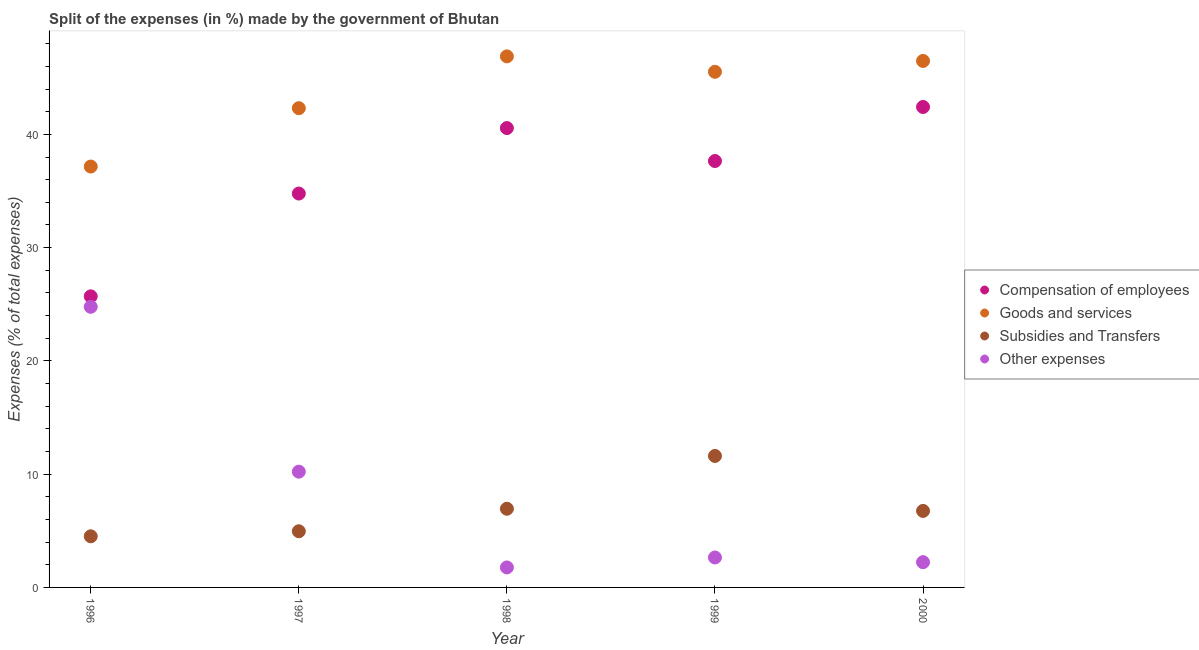Is the number of dotlines equal to the number of legend labels?
Give a very brief answer. Yes. What is the percentage of amount spent on other expenses in 1998?
Provide a short and direct response. 1.76. Across all years, what is the maximum percentage of amount spent on goods and services?
Offer a terse response. 46.88. Across all years, what is the minimum percentage of amount spent on other expenses?
Offer a terse response. 1.76. In which year was the percentage of amount spent on goods and services minimum?
Provide a succinct answer. 1996. What is the total percentage of amount spent on other expenses in the graph?
Provide a short and direct response. 41.63. What is the difference between the percentage of amount spent on compensation of employees in 1996 and that in 2000?
Ensure brevity in your answer.  -16.72. What is the difference between the percentage of amount spent on goods and services in 1996 and the percentage of amount spent on other expenses in 2000?
Provide a succinct answer. 34.93. What is the average percentage of amount spent on subsidies per year?
Your answer should be compact. 6.96. In the year 2000, what is the difference between the percentage of amount spent on goods and services and percentage of amount spent on subsidies?
Your answer should be very brief. 39.73. What is the ratio of the percentage of amount spent on goods and services in 1996 to that in 1998?
Your answer should be very brief. 0.79. What is the difference between the highest and the second highest percentage of amount spent on subsidies?
Your response must be concise. 4.66. What is the difference between the highest and the lowest percentage of amount spent on subsidies?
Ensure brevity in your answer.  7.09. Is the sum of the percentage of amount spent on compensation of employees in 1996 and 1997 greater than the maximum percentage of amount spent on goods and services across all years?
Keep it short and to the point. Yes. Is it the case that in every year, the sum of the percentage of amount spent on goods and services and percentage of amount spent on compensation of employees is greater than the sum of percentage of amount spent on subsidies and percentage of amount spent on other expenses?
Offer a very short reply. Yes. Does the percentage of amount spent on goods and services monotonically increase over the years?
Provide a short and direct response. No. Is the percentage of amount spent on other expenses strictly greater than the percentage of amount spent on compensation of employees over the years?
Provide a succinct answer. No. Is the percentage of amount spent on subsidies strictly less than the percentage of amount spent on other expenses over the years?
Make the answer very short. No. How many years are there in the graph?
Provide a succinct answer. 5. Does the graph contain any zero values?
Ensure brevity in your answer.  No. Does the graph contain grids?
Make the answer very short. No. How are the legend labels stacked?
Keep it short and to the point. Vertical. What is the title of the graph?
Offer a very short reply. Split of the expenses (in %) made by the government of Bhutan. Does "Rule based governance" appear as one of the legend labels in the graph?
Provide a short and direct response. No. What is the label or title of the Y-axis?
Offer a very short reply. Expenses (% of total expenses). What is the Expenses (% of total expenses) of Compensation of employees in 1996?
Give a very brief answer. 25.7. What is the Expenses (% of total expenses) in Goods and services in 1996?
Your response must be concise. 37.16. What is the Expenses (% of total expenses) in Subsidies and Transfers in 1996?
Keep it short and to the point. 4.51. What is the Expenses (% of total expenses) in Other expenses in 1996?
Provide a succinct answer. 24.77. What is the Expenses (% of total expenses) in Compensation of employees in 1997?
Provide a short and direct response. 34.77. What is the Expenses (% of total expenses) in Goods and services in 1997?
Your answer should be very brief. 42.31. What is the Expenses (% of total expenses) of Subsidies and Transfers in 1997?
Your answer should be compact. 4.96. What is the Expenses (% of total expenses) of Other expenses in 1997?
Your answer should be compact. 10.22. What is the Expenses (% of total expenses) of Compensation of employees in 1998?
Give a very brief answer. 40.56. What is the Expenses (% of total expenses) of Goods and services in 1998?
Provide a succinct answer. 46.88. What is the Expenses (% of total expenses) in Subsidies and Transfers in 1998?
Offer a terse response. 6.95. What is the Expenses (% of total expenses) of Other expenses in 1998?
Provide a short and direct response. 1.76. What is the Expenses (% of total expenses) in Compensation of employees in 1999?
Provide a short and direct response. 37.65. What is the Expenses (% of total expenses) in Goods and services in 1999?
Your answer should be compact. 45.52. What is the Expenses (% of total expenses) in Subsidies and Transfers in 1999?
Keep it short and to the point. 11.61. What is the Expenses (% of total expenses) in Other expenses in 1999?
Your response must be concise. 2.64. What is the Expenses (% of total expenses) of Compensation of employees in 2000?
Your response must be concise. 42.42. What is the Expenses (% of total expenses) of Goods and services in 2000?
Provide a short and direct response. 46.48. What is the Expenses (% of total expenses) in Subsidies and Transfers in 2000?
Provide a succinct answer. 6.76. What is the Expenses (% of total expenses) in Other expenses in 2000?
Offer a terse response. 2.23. Across all years, what is the maximum Expenses (% of total expenses) of Compensation of employees?
Offer a terse response. 42.42. Across all years, what is the maximum Expenses (% of total expenses) in Goods and services?
Provide a succinct answer. 46.88. Across all years, what is the maximum Expenses (% of total expenses) of Subsidies and Transfers?
Offer a very short reply. 11.61. Across all years, what is the maximum Expenses (% of total expenses) of Other expenses?
Offer a terse response. 24.77. Across all years, what is the minimum Expenses (% of total expenses) in Compensation of employees?
Offer a very short reply. 25.7. Across all years, what is the minimum Expenses (% of total expenses) of Goods and services?
Provide a short and direct response. 37.16. Across all years, what is the minimum Expenses (% of total expenses) in Subsidies and Transfers?
Offer a terse response. 4.51. Across all years, what is the minimum Expenses (% of total expenses) in Other expenses?
Your answer should be compact. 1.76. What is the total Expenses (% of total expenses) in Compensation of employees in the graph?
Provide a succinct answer. 181.09. What is the total Expenses (% of total expenses) in Goods and services in the graph?
Keep it short and to the point. 218.35. What is the total Expenses (% of total expenses) in Subsidies and Transfers in the graph?
Offer a very short reply. 34.78. What is the total Expenses (% of total expenses) in Other expenses in the graph?
Your response must be concise. 41.63. What is the difference between the Expenses (% of total expenses) of Compensation of employees in 1996 and that in 1997?
Give a very brief answer. -9.07. What is the difference between the Expenses (% of total expenses) of Goods and services in 1996 and that in 1997?
Provide a succinct answer. -5.15. What is the difference between the Expenses (% of total expenses) of Subsidies and Transfers in 1996 and that in 1997?
Ensure brevity in your answer.  -0.44. What is the difference between the Expenses (% of total expenses) of Other expenses in 1996 and that in 1997?
Your response must be concise. 14.55. What is the difference between the Expenses (% of total expenses) of Compensation of employees in 1996 and that in 1998?
Provide a succinct answer. -14.86. What is the difference between the Expenses (% of total expenses) in Goods and services in 1996 and that in 1998?
Offer a terse response. -9.73. What is the difference between the Expenses (% of total expenses) in Subsidies and Transfers in 1996 and that in 1998?
Your answer should be compact. -2.43. What is the difference between the Expenses (% of total expenses) in Other expenses in 1996 and that in 1998?
Your response must be concise. 23.01. What is the difference between the Expenses (% of total expenses) of Compensation of employees in 1996 and that in 1999?
Your answer should be very brief. -11.95. What is the difference between the Expenses (% of total expenses) in Goods and services in 1996 and that in 1999?
Your answer should be compact. -8.36. What is the difference between the Expenses (% of total expenses) of Subsidies and Transfers in 1996 and that in 1999?
Your answer should be very brief. -7.09. What is the difference between the Expenses (% of total expenses) of Other expenses in 1996 and that in 1999?
Provide a short and direct response. 22.13. What is the difference between the Expenses (% of total expenses) of Compensation of employees in 1996 and that in 2000?
Your answer should be very brief. -16.72. What is the difference between the Expenses (% of total expenses) in Goods and services in 1996 and that in 2000?
Provide a succinct answer. -9.32. What is the difference between the Expenses (% of total expenses) of Subsidies and Transfers in 1996 and that in 2000?
Offer a very short reply. -2.24. What is the difference between the Expenses (% of total expenses) of Other expenses in 1996 and that in 2000?
Offer a terse response. 22.55. What is the difference between the Expenses (% of total expenses) of Compensation of employees in 1997 and that in 1998?
Provide a succinct answer. -5.78. What is the difference between the Expenses (% of total expenses) in Goods and services in 1997 and that in 1998?
Your answer should be compact. -4.57. What is the difference between the Expenses (% of total expenses) of Subsidies and Transfers in 1997 and that in 1998?
Give a very brief answer. -1.99. What is the difference between the Expenses (% of total expenses) of Other expenses in 1997 and that in 1998?
Make the answer very short. 8.46. What is the difference between the Expenses (% of total expenses) of Compensation of employees in 1997 and that in 1999?
Offer a terse response. -2.87. What is the difference between the Expenses (% of total expenses) in Goods and services in 1997 and that in 1999?
Make the answer very short. -3.21. What is the difference between the Expenses (% of total expenses) in Subsidies and Transfers in 1997 and that in 1999?
Offer a very short reply. -6.65. What is the difference between the Expenses (% of total expenses) in Other expenses in 1997 and that in 1999?
Provide a short and direct response. 7.58. What is the difference between the Expenses (% of total expenses) of Compensation of employees in 1997 and that in 2000?
Keep it short and to the point. -7.64. What is the difference between the Expenses (% of total expenses) in Goods and services in 1997 and that in 2000?
Your answer should be compact. -4.17. What is the difference between the Expenses (% of total expenses) of Subsidies and Transfers in 1997 and that in 2000?
Your answer should be compact. -1.8. What is the difference between the Expenses (% of total expenses) in Other expenses in 1997 and that in 2000?
Offer a terse response. 7.99. What is the difference between the Expenses (% of total expenses) of Compensation of employees in 1998 and that in 1999?
Make the answer very short. 2.91. What is the difference between the Expenses (% of total expenses) in Goods and services in 1998 and that in 1999?
Provide a short and direct response. 1.36. What is the difference between the Expenses (% of total expenses) of Subsidies and Transfers in 1998 and that in 1999?
Provide a succinct answer. -4.66. What is the difference between the Expenses (% of total expenses) in Other expenses in 1998 and that in 1999?
Give a very brief answer. -0.88. What is the difference between the Expenses (% of total expenses) of Compensation of employees in 1998 and that in 2000?
Make the answer very short. -1.86. What is the difference between the Expenses (% of total expenses) of Goods and services in 1998 and that in 2000?
Keep it short and to the point. 0.4. What is the difference between the Expenses (% of total expenses) in Subsidies and Transfers in 1998 and that in 2000?
Give a very brief answer. 0.19. What is the difference between the Expenses (% of total expenses) of Other expenses in 1998 and that in 2000?
Make the answer very short. -0.46. What is the difference between the Expenses (% of total expenses) of Compensation of employees in 1999 and that in 2000?
Provide a succinct answer. -4.77. What is the difference between the Expenses (% of total expenses) of Goods and services in 1999 and that in 2000?
Give a very brief answer. -0.96. What is the difference between the Expenses (% of total expenses) in Subsidies and Transfers in 1999 and that in 2000?
Provide a short and direct response. 4.85. What is the difference between the Expenses (% of total expenses) in Other expenses in 1999 and that in 2000?
Give a very brief answer. 0.41. What is the difference between the Expenses (% of total expenses) in Compensation of employees in 1996 and the Expenses (% of total expenses) in Goods and services in 1997?
Your answer should be compact. -16.61. What is the difference between the Expenses (% of total expenses) in Compensation of employees in 1996 and the Expenses (% of total expenses) in Subsidies and Transfers in 1997?
Provide a short and direct response. 20.74. What is the difference between the Expenses (% of total expenses) of Compensation of employees in 1996 and the Expenses (% of total expenses) of Other expenses in 1997?
Your answer should be very brief. 15.48. What is the difference between the Expenses (% of total expenses) of Goods and services in 1996 and the Expenses (% of total expenses) of Subsidies and Transfers in 1997?
Offer a very short reply. 32.2. What is the difference between the Expenses (% of total expenses) in Goods and services in 1996 and the Expenses (% of total expenses) in Other expenses in 1997?
Offer a very short reply. 26.94. What is the difference between the Expenses (% of total expenses) of Subsidies and Transfers in 1996 and the Expenses (% of total expenses) of Other expenses in 1997?
Make the answer very short. -5.71. What is the difference between the Expenses (% of total expenses) of Compensation of employees in 1996 and the Expenses (% of total expenses) of Goods and services in 1998?
Give a very brief answer. -21.18. What is the difference between the Expenses (% of total expenses) in Compensation of employees in 1996 and the Expenses (% of total expenses) in Subsidies and Transfers in 1998?
Provide a short and direct response. 18.75. What is the difference between the Expenses (% of total expenses) of Compensation of employees in 1996 and the Expenses (% of total expenses) of Other expenses in 1998?
Keep it short and to the point. 23.93. What is the difference between the Expenses (% of total expenses) of Goods and services in 1996 and the Expenses (% of total expenses) of Subsidies and Transfers in 1998?
Make the answer very short. 30.21. What is the difference between the Expenses (% of total expenses) of Goods and services in 1996 and the Expenses (% of total expenses) of Other expenses in 1998?
Make the answer very short. 35.39. What is the difference between the Expenses (% of total expenses) of Subsidies and Transfers in 1996 and the Expenses (% of total expenses) of Other expenses in 1998?
Offer a terse response. 2.75. What is the difference between the Expenses (% of total expenses) of Compensation of employees in 1996 and the Expenses (% of total expenses) of Goods and services in 1999?
Your answer should be compact. -19.82. What is the difference between the Expenses (% of total expenses) in Compensation of employees in 1996 and the Expenses (% of total expenses) in Subsidies and Transfers in 1999?
Keep it short and to the point. 14.09. What is the difference between the Expenses (% of total expenses) of Compensation of employees in 1996 and the Expenses (% of total expenses) of Other expenses in 1999?
Offer a very short reply. 23.06. What is the difference between the Expenses (% of total expenses) of Goods and services in 1996 and the Expenses (% of total expenses) of Subsidies and Transfers in 1999?
Make the answer very short. 25.55. What is the difference between the Expenses (% of total expenses) in Goods and services in 1996 and the Expenses (% of total expenses) in Other expenses in 1999?
Provide a succinct answer. 34.51. What is the difference between the Expenses (% of total expenses) of Subsidies and Transfers in 1996 and the Expenses (% of total expenses) of Other expenses in 1999?
Keep it short and to the point. 1.87. What is the difference between the Expenses (% of total expenses) in Compensation of employees in 1996 and the Expenses (% of total expenses) in Goods and services in 2000?
Offer a very short reply. -20.78. What is the difference between the Expenses (% of total expenses) in Compensation of employees in 1996 and the Expenses (% of total expenses) in Subsidies and Transfers in 2000?
Provide a succinct answer. 18.94. What is the difference between the Expenses (% of total expenses) in Compensation of employees in 1996 and the Expenses (% of total expenses) in Other expenses in 2000?
Provide a succinct answer. 23.47. What is the difference between the Expenses (% of total expenses) of Goods and services in 1996 and the Expenses (% of total expenses) of Subsidies and Transfers in 2000?
Your response must be concise. 30.4. What is the difference between the Expenses (% of total expenses) in Goods and services in 1996 and the Expenses (% of total expenses) in Other expenses in 2000?
Your answer should be very brief. 34.93. What is the difference between the Expenses (% of total expenses) in Subsidies and Transfers in 1996 and the Expenses (% of total expenses) in Other expenses in 2000?
Offer a terse response. 2.28. What is the difference between the Expenses (% of total expenses) in Compensation of employees in 1997 and the Expenses (% of total expenses) in Goods and services in 1998?
Your answer should be very brief. -12.11. What is the difference between the Expenses (% of total expenses) of Compensation of employees in 1997 and the Expenses (% of total expenses) of Subsidies and Transfers in 1998?
Your answer should be compact. 27.83. What is the difference between the Expenses (% of total expenses) of Compensation of employees in 1997 and the Expenses (% of total expenses) of Other expenses in 1998?
Provide a succinct answer. 33.01. What is the difference between the Expenses (% of total expenses) of Goods and services in 1997 and the Expenses (% of total expenses) of Subsidies and Transfers in 1998?
Your answer should be compact. 35.36. What is the difference between the Expenses (% of total expenses) of Goods and services in 1997 and the Expenses (% of total expenses) of Other expenses in 1998?
Offer a terse response. 40.54. What is the difference between the Expenses (% of total expenses) of Subsidies and Transfers in 1997 and the Expenses (% of total expenses) of Other expenses in 1998?
Provide a short and direct response. 3.19. What is the difference between the Expenses (% of total expenses) of Compensation of employees in 1997 and the Expenses (% of total expenses) of Goods and services in 1999?
Keep it short and to the point. -10.75. What is the difference between the Expenses (% of total expenses) of Compensation of employees in 1997 and the Expenses (% of total expenses) of Subsidies and Transfers in 1999?
Keep it short and to the point. 23.17. What is the difference between the Expenses (% of total expenses) in Compensation of employees in 1997 and the Expenses (% of total expenses) in Other expenses in 1999?
Your response must be concise. 32.13. What is the difference between the Expenses (% of total expenses) in Goods and services in 1997 and the Expenses (% of total expenses) in Subsidies and Transfers in 1999?
Offer a terse response. 30.7. What is the difference between the Expenses (% of total expenses) in Goods and services in 1997 and the Expenses (% of total expenses) in Other expenses in 1999?
Provide a succinct answer. 39.67. What is the difference between the Expenses (% of total expenses) in Subsidies and Transfers in 1997 and the Expenses (% of total expenses) in Other expenses in 1999?
Your answer should be very brief. 2.31. What is the difference between the Expenses (% of total expenses) of Compensation of employees in 1997 and the Expenses (% of total expenses) of Goods and services in 2000?
Make the answer very short. -11.71. What is the difference between the Expenses (% of total expenses) in Compensation of employees in 1997 and the Expenses (% of total expenses) in Subsidies and Transfers in 2000?
Your response must be concise. 28.02. What is the difference between the Expenses (% of total expenses) in Compensation of employees in 1997 and the Expenses (% of total expenses) in Other expenses in 2000?
Provide a short and direct response. 32.55. What is the difference between the Expenses (% of total expenses) of Goods and services in 1997 and the Expenses (% of total expenses) of Subsidies and Transfers in 2000?
Provide a short and direct response. 35.55. What is the difference between the Expenses (% of total expenses) of Goods and services in 1997 and the Expenses (% of total expenses) of Other expenses in 2000?
Keep it short and to the point. 40.08. What is the difference between the Expenses (% of total expenses) of Subsidies and Transfers in 1997 and the Expenses (% of total expenses) of Other expenses in 2000?
Make the answer very short. 2.73. What is the difference between the Expenses (% of total expenses) of Compensation of employees in 1998 and the Expenses (% of total expenses) of Goods and services in 1999?
Keep it short and to the point. -4.97. What is the difference between the Expenses (% of total expenses) of Compensation of employees in 1998 and the Expenses (% of total expenses) of Subsidies and Transfers in 1999?
Ensure brevity in your answer.  28.95. What is the difference between the Expenses (% of total expenses) of Compensation of employees in 1998 and the Expenses (% of total expenses) of Other expenses in 1999?
Your answer should be compact. 37.91. What is the difference between the Expenses (% of total expenses) of Goods and services in 1998 and the Expenses (% of total expenses) of Subsidies and Transfers in 1999?
Provide a short and direct response. 35.28. What is the difference between the Expenses (% of total expenses) of Goods and services in 1998 and the Expenses (% of total expenses) of Other expenses in 1999?
Make the answer very short. 44.24. What is the difference between the Expenses (% of total expenses) in Subsidies and Transfers in 1998 and the Expenses (% of total expenses) in Other expenses in 1999?
Make the answer very short. 4.3. What is the difference between the Expenses (% of total expenses) of Compensation of employees in 1998 and the Expenses (% of total expenses) of Goods and services in 2000?
Keep it short and to the point. -5.93. What is the difference between the Expenses (% of total expenses) in Compensation of employees in 1998 and the Expenses (% of total expenses) in Subsidies and Transfers in 2000?
Offer a terse response. 33.8. What is the difference between the Expenses (% of total expenses) of Compensation of employees in 1998 and the Expenses (% of total expenses) of Other expenses in 2000?
Make the answer very short. 38.33. What is the difference between the Expenses (% of total expenses) in Goods and services in 1998 and the Expenses (% of total expenses) in Subsidies and Transfers in 2000?
Provide a succinct answer. 40.13. What is the difference between the Expenses (% of total expenses) in Goods and services in 1998 and the Expenses (% of total expenses) in Other expenses in 2000?
Your response must be concise. 44.66. What is the difference between the Expenses (% of total expenses) of Subsidies and Transfers in 1998 and the Expenses (% of total expenses) of Other expenses in 2000?
Provide a short and direct response. 4.72. What is the difference between the Expenses (% of total expenses) in Compensation of employees in 1999 and the Expenses (% of total expenses) in Goods and services in 2000?
Your response must be concise. -8.83. What is the difference between the Expenses (% of total expenses) of Compensation of employees in 1999 and the Expenses (% of total expenses) of Subsidies and Transfers in 2000?
Make the answer very short. 30.89. What is the difference between the Expenses (% of total expenses) of Compensation of employees in 1999 and the Expenses (% of total expenses) of Other expenses in 2000?
Provide a succinct answer. 35.42. What is the difference between the Expenses (% of total expenses) of Goods and services in 1999 and the Expenses (% of total expenses) of Subsidies and Transfers in 2000?
Your answer should be very brief. 38.77. What is the difference between the Expenses (% of total expenses) of Goods and services in 1999 and the Expenses (% of total expenses) of Other expenses in 2000?
Provide a succinct answer. 43.29. What is the difference between the Expenses (% of total expenses) in Subsidies and Transfers in 1999 and the Expenses (% of total expenses) in Other expenses in 2000?
Your answer should be very brief. 9.38. What is the average Expenses (% of total expenses) in Compensation of employees per year?
Offer a very short reply. 36.22. What is the average Expenses (% of total expenses) in Goods and services per year?
Your response must be concise. 43.67. What is the average Expenses (% of total expenses) in Subsidies and Transfers per year?
Offer a very short reply. 6.96. What is the average Expenses (% of total expenses) in Other expenses per year?
Your response must be concise. 8.33. In the year 1996, what is the difference between the Expenses (% of total expenses) of Compensation of employees and Expenses (% of total expenses) of Goods and services?
Your answer should be very brief. -11.46. In the year 1996, what is the difference between the Expenses (% of total expenses) of Compensation of employees and Expenses (% of total expenses) of Subsidies and Transfers?
Your response must be concise. 21.19. In the year 1996, what is the difference between the Expenses (% of total expenses) of Compensation of employees and Expenses (% of total expenses) of Other expenses?
Your response must be concise. 0.92. In the year 1996, what is the difference between the Expenses (% of total expenses) of Goods and services and Expenses (% of total expenses) of Subsidies and Transfers?
Keep it short and to the point. 32.64. In the year 1996, what is the difference between the Expenses (% of total expenses) of Goods and services and Expenses (% of total expenses) of Other expenses?
Your answer should be compact. 12.38. In the year 1996, what is the difference between the Expenses (% of total expenses) of Subsidies and Transfers and Expenses (% of total expenses) of Other expenses?
Make the answer very short. -20.26. In the year 1997, what is the difference between the Expenses (% of total expenses) of Compensation of employees and Expenses (% of total expenses) of Goods and services?
Offer a terse response. -7.54. In the year 1997, what is the difference between the Expenses (% of total expenses) in Compensation of employees and Expenses (% of total expenses) in Subsidies and Transfers?
Make the answer very short. 29.82. In the year 1997, what is the difference between the Expenses (% of total expenses) in Compensation of employees and Expenses (% of total expenses) in Other expenses?
Offer a terse response. 24.55. In the year 1997, what is the difference between the Expenses (% of total expenses) in Goods and services and Expenses (% of total expenses) in Subsidies and Transfers?
Provide a succinct answer. 37.35. In the year 1997, what is the difference between the Expenses (% of total expenses) of Goods and services and Expenses (% of total expenses) of Other expenses?
Provide a succinct answer. 32.09. In the year 1997, what is the difference between the Expenses (% of total expenses) in Subsidies and Transfers and Expenses (% of total expenses) in Other expenses?
Your response must be concise. -5.26. In the year 1998, what is the difference between the Expenses (% of total expenses) in Compensation of employees and Expenses (% of total expenses) in Goods and services?
Offer a terse response. -6.33. In the year 1998, what is the difference between the Expenses (% of total expenses) of Compensation of employees and Expenses (% of total expenses) of Subsidies and Transfers?
Your answer should be compact. 33.61. In the year 1998, what is the difference between the Expenses (% of total expenses) of Compensation of employees and Expenses (% of total expenses) of Other expenses?
Keep it short and to the point. 38.79. In the year 1998, what is the difference between the Expenses (% of total expenses) of Goods and services and Expenses (% of total expenses) of Subsidies and Transfers?
Ensure brevity in your answer.  39.94. In the year 1998, what is the difference between the Expenses (% of total expenses) of Goods and services and Expenses (% of total expenses) of Other expenses?
Provide a short and direct response. 45.12. In the year 1998, what is the difference between the Expenses (% of total expenses) in Subsidies and Transfers and Expenses (% of total expenses) in Other expenses?
Keep it short and to the point. 5.18. In the year 1999, what is the difference between the Expenses (% of total expenses) in Compensation of employees and Expenses (% of total expenses) in Goods and services?
Give a very brief answer. -7.88. In the year 1999, what is the difference between the Expenses (% of total expenses) of Compensation of employees and Expenses (% of total expenses) of Subsidies and Transfers?
Offer a very short reply. 26.04. In the year 1999, what is the difference between the Expenses (% of total expenses) of Compensation of employees and Expenses (% of total expenses) of Other expenses?
Make the answer very short. 35. In the year 1999, what is the difference between the Expenses (% of total expenses) of Goods and services and Expenses (% of total expenses) of Subsidies and Transfers?
Keep it short and to the point. 33.92. In the year 1999, what is the difference between the Expenses (% of total expenses) of Goods and services and Expenses (% of total expenses) of Other expenses?
Ensure brevity in your answer.  42.88. In the year 1999, what is the difference between the Expenses (% of total expenses) in Subsidies and Transfers and Expenses (% of total expenses) in Other expenses?
Provide a succinct answer. 8.96. In the year 2000, what is the difference between the Expenses (% of total expenses) of Compensation of employees and Expenses (% of total expenses) of Goods and services?
Give a very brief answer. -4.06. In the year 2000, what is the difference between the Expenses (% of total expenses) of Compensation of employees and Expenses (% of total expenses) of Subsidies and Transfers?
Provide a succinct answer. 35.66. In the year 2000, what is the difference between the Expenses (% of total expenses) in Compensation of employees and Expenses (% of total expenses) in Other expenses?
Give a very brief answer. 40.19. In the year 2000, what is the difference between the Expenses (% of total expenses) of Goods and services and Expenses (% of total expenses) of Subsidies and Transfers?
Your answer should be very brief. 39.73. In the year 2000, what is the difference between the Expenses (% of total expenses) of Goods and services and Expenses (% of total expenses) of Other expenses?
Your answer should be compact. 44.25. In the year 2000, what is the difference between the Expenses (% of total expenses) of Subsidies and Transfers and Expenses (% of total expenses) of Other expenses?
Your answer should be very brief. 4.53. What is the ratio of the Expenses (% of total expenses) of Compensation of employees in 1996 to that in 1997?
Your answer should be very brief. 0.74. What is the ratio of the Expenses (% of total expenses) of Goods and services in 1996 to that in 1997?
Your answer should be very brief. 0.88. What is the ratio of the Expenses (% of total expenses) in Subsidies and Transfers in 1996 to that in 1997?
Give a very brief answer. 0.91. What is the ratio of the Expenses (% of total expenses) in Other expenses in 1996 to that in 1997?
Your answer should be compact. 2.42. What is the ratio of the Expenses (% of total expenses) in Compensation of employees in 1996 to that in 1998?
Offer a terse response. 0.63. What is the ratio of the Expenses (% of total expenses) in Goods and services in 1996 to that in 1998?
Provide a succinct answer. 0.79. What is the ratio of the Expenses (% of total expenses) in Subsidies and Transfers in 1996 to that in 1998?
Provide a succinct answer. 0.65. What is the ratio of the Expenses (% of total expenses) of Other expenses in 1996 to that in 1998?
Offer a terse response. 14.04. What is the ratio of the Expenses (% of total expenses) of Compensation of employees in 1996 to that in 1999?
Provide a short and direct response. 0.68. What is the ratio of the Expenses (% of total expenses) of Goods and services in 1996 to that in 1999?
Offer a terse response. 0.82. What is the ratio of the Expenses (% of total expenses) in Subsidies and Transfers in 1996 to that in 1999?
Give a very brief answer. 0.39. What is the ratio of the Expenses (% of total expenses) of Other expenses in 1996 to that in 1999?
Provide a short and direct response. 9.37. What is the ratio of the Expenses (% of total expenses) of Compensation of employees in 1996 to that in 2000?
Provide a succinct answer. 0.61. What is the ratio of the Expenses (% of total expenses) of Goods and services in 1996 to that in 2000?
Make the answer very short. 0.8. What is the ratio of the Expenses (% of total expenses) in Subsidies and Transfers in 1996 to that in 2000?
Your answer should be compact. 0.67. What is the ratio of the Expenses (% of total expenses) of Other expenses in 1996 to that in 2000?
Offer a very short reply. 11.11. What is the ratio of the Expenses (% of total expenses) of Compensation of employees in 1997 to that in 1998?
Provide a succinct answer. 0.86. What is the ratio of the Expenses (% of total expenses) in Goods and services in 1997 to that in 1998?
Provide a short and direct response. 0.9. What is the ratio of the Expenses (% of total expenses) in Subsidies and Transfers in 1997 to that in 1998?
Your answer should be very brief. 0.71. What is the ratio of the Expenses (% of total expenses) of Other expenses in 1997 to that in 1998?
Keep it short and to the point. 5.79. What is the ratio of the Expenses (% of total expenses) of Compensation of employees in 1997 to that in 1999?
Give a very brief answer. 0.92. What is the ratio of the Expenses (% of total expenses) of Goods and services in 1997 to that in 1999?
Provide a succinct answer. 0.93. What is the ratio of the Expenses (% of total expenses) of Subsidies and Transfers in 1997 to that in 1999?
Give a very brief answer. 0.43. What is the ratio of the Expenses (% of total expenses) in Other expenses in 1997 to that in 1999?
Give a very brief answer. 3.87. What is the ratio of the Expenses (% of total expenses) of Compensation of employees in 1997 to that in 2000?
Keep it short and to the point. 0.82. What is the ratio of the Expenses (% of total expenses) in Goods and services in 1997 to that in 2000?
Make the answer very short. 0.91. What is the ratio of the Expenses (% of total expenses) of Subsidies and Transfers in 1997 to that in 2000?
Provide a short and direct response. 0.73. What is the ratio of the Expenses (% of total expenses) in Other expenses in 1997 to that in 2000?
Make the answer very short. 4.58. What is the ratio of the Expenses (% of total expenses) in Compensation of employees in 1998 to that in 1999?
Your answer should be compact. 1.08. What is the ratio of the Expenses (% of total expenses) of Goods and services in 1998 to that in 1999?
Offer a terse response. 1.03. What is the ratio of the Expenses (% of total expenses) of Subsidies and Transfers in 1998 to that in 1999?
Your answer should be compact. 0.6. What is the ratio of the Expenses (% of total expenses) in Other expenses in 1998 to that in 1999?
Keep it short and to the point. 0.67. What is the ratio of the Expenses (% of total expenses) in Compensation of employees in 1998 to that in 2000?
Provide a succinct answer. 0.96. What is the ratio of the Expenses (% of total expenses) in Goods and services in 1998 to that in 2000?
Give a very brief answer. 1.01. What is the ratio of the Expenses (% of total expenses) of Subsidies and Transfers in 1998 to that in 2000?
Make the answer very short. 1.03. What is the ratio of the Expenses (% of total expenses) of Other expenses in 1998 to that in 2000?
Your answer should be compact. 0.79. What is the ratio of the Expenses (% of total expenses) in Compensation of employees in 1999 to that in 2000?
Provide a short and direct response. 0.89. What is the ratio of the Expenses (% of total expenses) of Goods and services in 1999 to that in 2000?
Your answer should be very brief. 0.98. What is the ratio of the Expenses (% of total expenses) in Subsidies and Transfers in 1999 to that in 2000?
Keep it short and to the point. 1.72. What is the ratio of the Expenses (% of total expenses) of Other expenses in 1999 to that in 2000?
Ensure brevity in your answer.  1.19. What is the difference between the highest and the second highest Expenses (% of total expenses) of Compensation of employees?
Offer a terse response. 1.86. What is the difference between the highest and the second highest Expenses (% of total expenses) in Goods and services?
Offer a terse response. 0.4. What is the difference between the highest and the second highest Expenses (% of total expenses) of Subsidies and Transfers?
Provide a succinct answer. 4.66. What is the difference between the highest and the second highest Expenses (% of total expenses) of Other expenses?
Your answer should be compact. 14.55. What is the difference between the highest and the lowest Expenses (% of total expenses) in Compensation of employees?
Provide a short and direct response. 16.72. What is the difference between the highest and the lowest Expenses (% of total expenses) in Goods and services?
Offer a very short reply. 9.73. What is the difference between the highest and the lowest Expenses (% of total expenses) in Subsidies and Transfers?
Offer a terse response. 7.09. What is the difference between the highest and the lowest Expenses (% of total expenses) of Other expenses?
Make the answer very short. 23.01. 